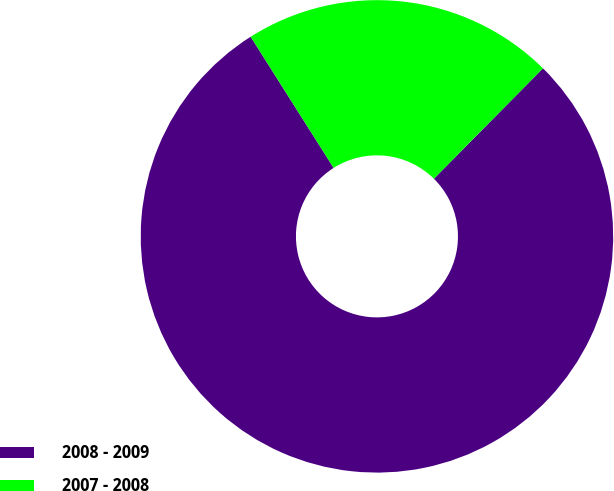Convert chart. <chart><loc_0><loc_0><loc_500><loc_500><pie_chart><fcel>2008 - 2009<fcel>2007 - 2008<nl><fcel>78.62%<fcel>21.38%<nl></chart> 